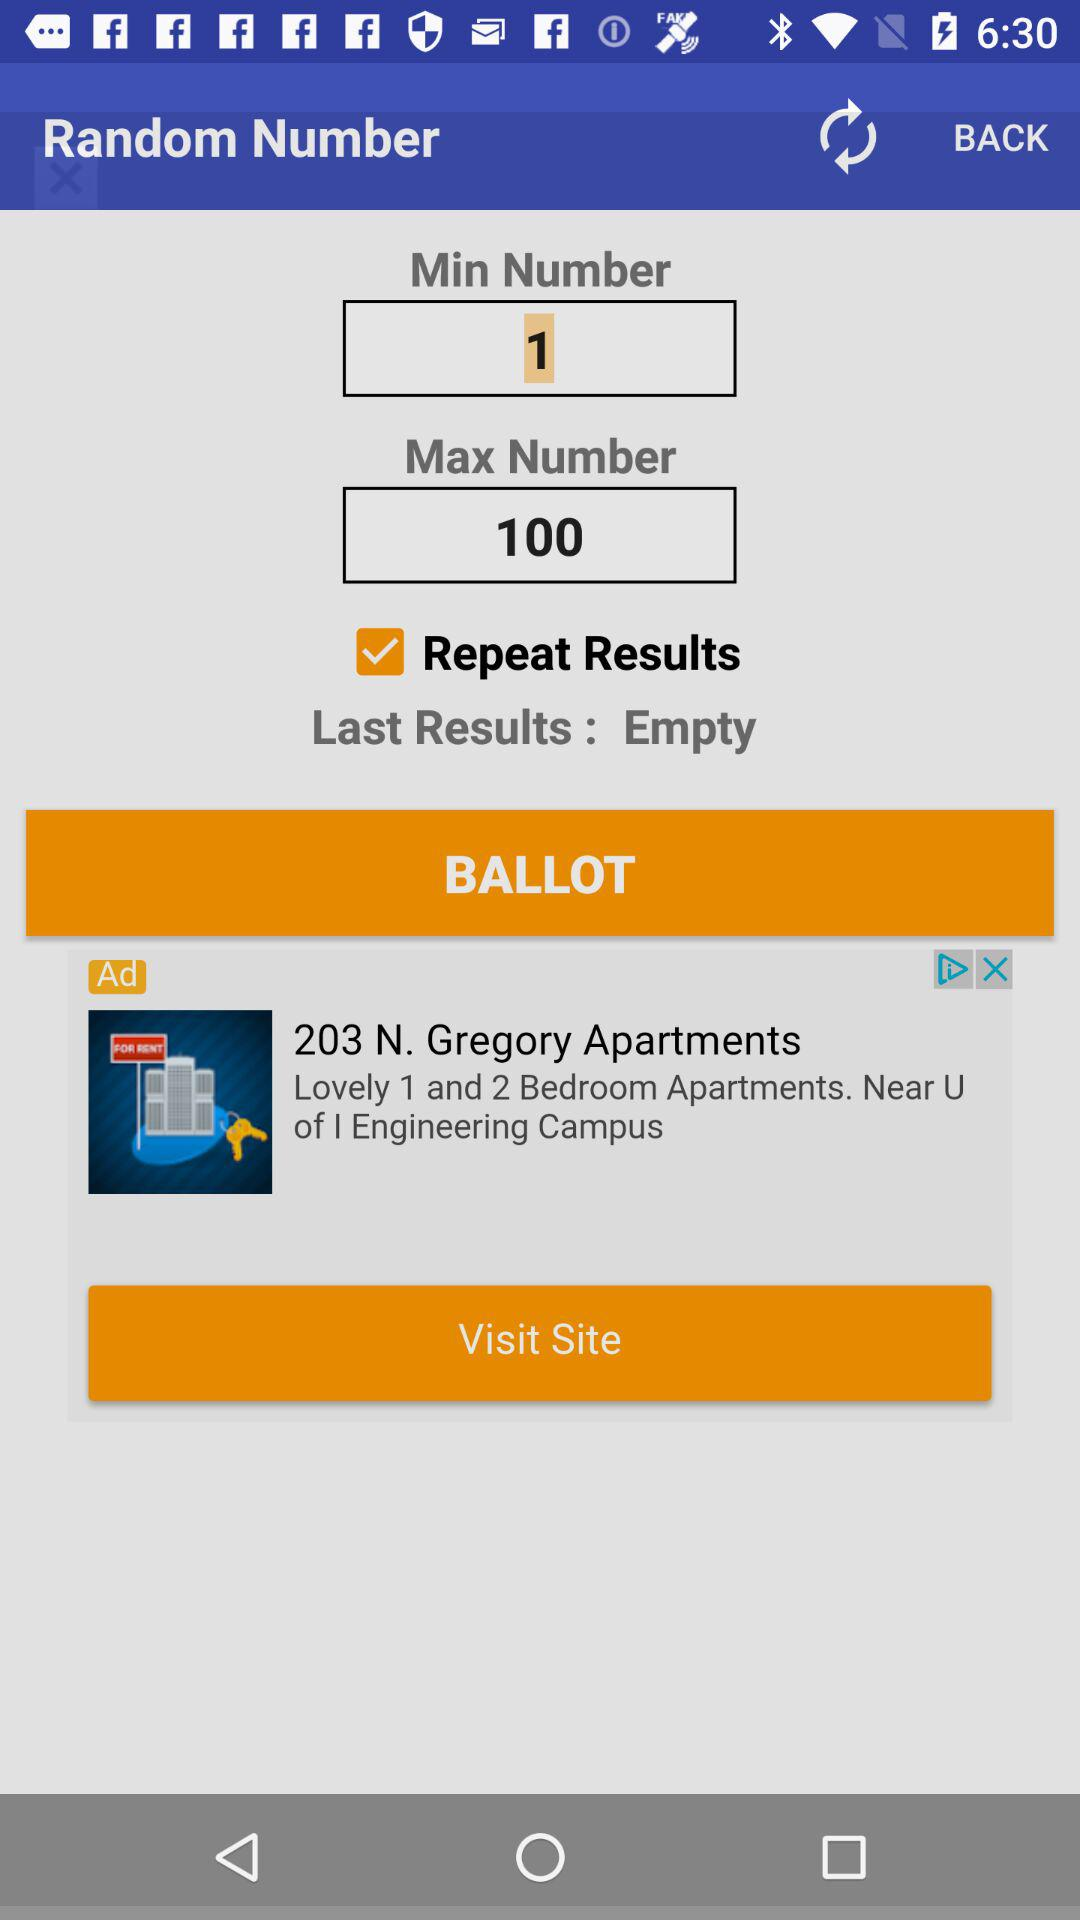What is the "Max Number"? The "Max Number" is 100. 